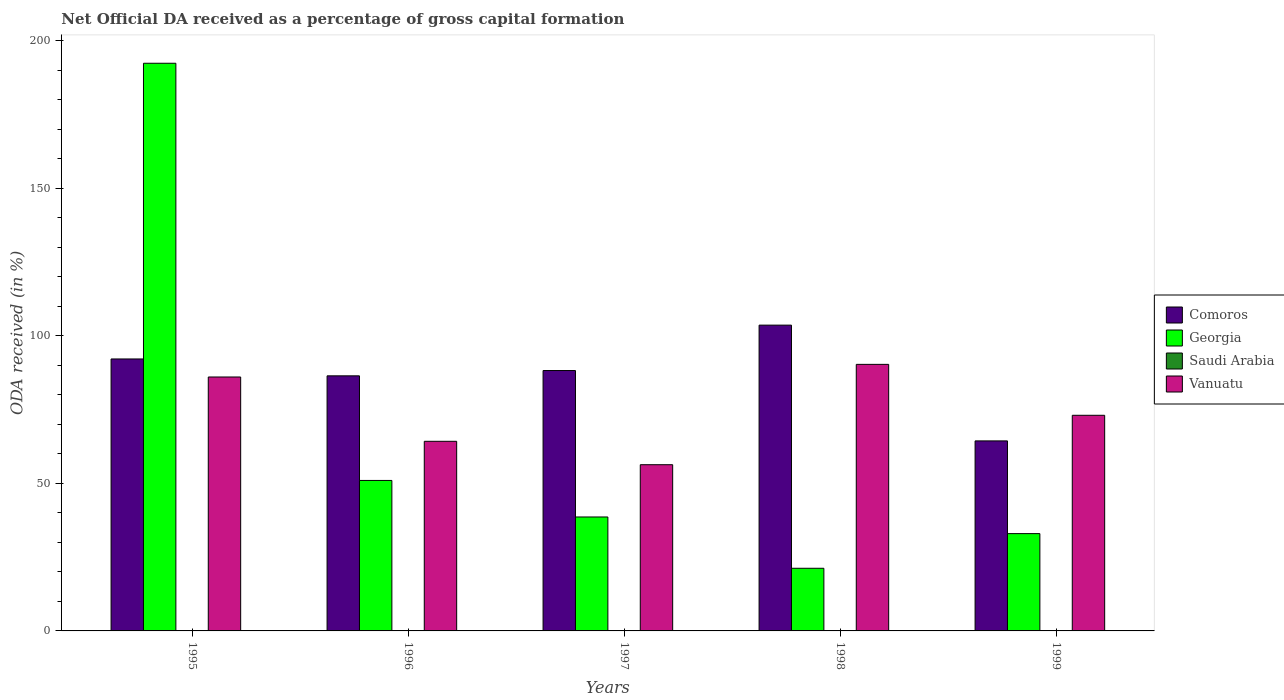How many groups of bars are there?
Keep it short and to the point. 5. Are the number of bars on each tick of the X-axis equal?
Offer a terse response. Yes. How many bars are there on the 2nd tick from the left?
Provide a short and direct response. 4. In how many cases, is the number of bars for a given year not equal to the number of legend labels?
Your answer should be very brief. 0. What is the net ODA received in Comoros in 1998?
Your answer should be very brief. 103.67. Across all years, what is the maximum net ODA received in Georgia?
Offer a very short reply. 192.44. Across all years, what is the minimum net ODA received in Comoros?
Make the answer very short. 64.42. In which year was the net ODA received in Saudi Arabia maximum?
Your answer should be compact. 1999. What is the total net ODA received in Saudi Arabia in the graph?
Ensure brevity in your answer.  0.23. What is the difference between the net ODA received in Saudi Arabia in 1998 and that in 1999?
Ensure brevity in your answer.  -0.01. What is the difference between the net ODA received in Georgia in 1996 and the net ODA received in Comoros in 1999?
Your answer should be very brief. -13.41. What is the average net ODA received in Saudi Arabia per year?
Make the answer very short. 0.05. In the year 1996, what is the difference between the net ODA received in Saudi Arabia and net ODA received in Comoros?
Give a very brief answer. -86.43. What is the ratio of the net ODA received in Vanuatu in 1998 to that in 1999?
Provide a short and direct response. 1.24. What is the difference between the highest and the second highest net ODA received in Saudi Arabia?
Provide a short and direct response. 0. What is the difference between the highest and the lowest net ODA received in Georgia?
Offer a terse response. 171.2. What does the 3rd bar from the left in 1996 represents?
Make the answer very short. Saudi Arabia. What does the 4th bar from the right in 1997 represents?
Your answer should be very brief. Comoros. How many bars are there?
Make the answer very short. 20. Are all the bars in the graph horizontal?
Provide a succinct answer. No. How many years are there in the graph?
Provide a succinct answer. 5. What is the difference between two consecutive major ticks on the Y-axis?
Ensure brevity in your answer.  50. Are the values on the major ticks of Y-axis written in scientific E-notation?
Your answer should be compact. No. Does the graph contain any zero values?
Offer a very short reply. No. Does the graph contain grids?
Give a very brief answer. No. How many legend labels are there?
Provide a short and direct response. 4. How are the legend labels stacked?
Offer a very short reply. Vertical. What is the title of the graph?
Keep it short and to the point. Net Official DA received as a percentage of gross capital formation. Does "Ghana" appear as one of the legend labels in the graph?
Your response must be concise. No. What is the label or title of the Y-axis?
Your answer should be very brief. ODA received (in %). What is the ODA received (in %) in Comoros in 1995?
Provide a succinct answer. 92.2. What is the ODA received (in %) of Georgia in 1995?
Your answer should be compact. 192.44. What is the ODA received (in %) of Saudi Arabia in 1995?
Your answer should be compact. 0.06. What is the ODA received (in %) in Vanuatu in 1995?
Your answer should be very brief. 86.09. What is the ODA received (in %) in Comoros in 1996?
Your response must be concise. 86.48. What is the ODA received (in %) in Georgia in 1996?
Keep it short and to the point. 51.01. What is the ODA received (in %) in Saudi Arabia in 1996?
Keep it short and to the point. 0.05. What is the ODA received (in %) of Vanuatu in 1996?
Give a very brief answer. 64.28. What is the ODA received (in %) of Comoros in 1997?
Your answer should be very brief. 88.27. What is the ODA received (in %) of Georgia in 1997?
Keep it short and to the point. 38.63. What is the ODA received (in %) of Saudi Arabia in 1997?
Provide a short and direct response. 0. What is the ODA received (in %) of Vanuatu in 1997?
Ensure brevity in your answer.  56.35. What is the ODA received (in %) in Comoros in 1998?
Keep it short and to the point. 103.67. What is the ODA received (in %) of Georgia in 1998?
Your answer should be very brief. 21.24. What is the ODA received (in %) of Saudi Arabia in 1998?
Keep it short and to the point. 0.05. What is the ODA received (in %) in Vanuatu in 1998?
Offer a terse response. 90.36. What is the ODA received (in %) in Comoros in 1999?
Provide a short and direct response. 64.42. What is the ODA received (in %) of Georgia in 1999?
Give a very brief answer. 32.99. What is the ODA received (in %) in Saudi Arabia in 1999?
Give a very brief answer. 0.07. What is the ODA received (in %) of Vanuatu in 1999?
Keep it short and to the point. 73.1. Across all years, what is the maximum ODA received (in %) in Comoros?
Provide a succinct answer. 103.67. Across all years, what is the maximum ODA received (in %) in Georgia?
Your answer should be very brief. 192.44. Across all years, what is the maximum ODA received (in %) of Saudi Arabia?
Your answer should be compact. 0.07. Across all years, what is the maximum ODA received (in %) of Vanuatu?
Your response must be concise. 90.36. Across all years, what is the minimum ODA received (in %) in Comoros?
Provide a short and direct response. 64.42. Across all years, what is the minimum ODA received (in %) of Georgia?
Provide a succinct answer. 21.24. Across all years, what is the minimum ODA received (in %) in Saudi Arabia?
Provide a succinct answer. 0. Across all years, what is the minimum ODA received (in %) in Vanuatu?
Offer a very short reply. 56.35. What is the total ODA received (in %) of Comoros in the graph?
Provide a succinct answer. 435.03. What is the total ODA received (in %) in Georgia in the graph?
Your answer should be compact. 336.31. What is the total ODA received (in %) in Saudi Arabia in the graph?
Offer a terse response. 0.23. What is the total ODA received (in %) of Vanuatu in the graph?
Your response must be concise. 370.18. What is the difference between the ODA received (in %) in Comoros in 1995 and that in 1996?
Your response must be concise. 5.72. What is the difference between the ODA received (in %) in Georgia in 1995 and that in 1996?
Offer a terse response. 141.43. What is the difference between the ODA received (in %) of Saudi Arabia in 1995 and that in 1996?
Your response must be concise. 0.01. What is the difference between the ODA received (in %) in Vanuatu in 1995 and that in 1996?
Ensure brevity in your answer.  21.81. What is the difference between the ODA received (in %) of Comoros in 1995 and that in 1997?
Offer a very short reply. 3.93. What is the difference between the ODA received (in %) in Georgia in 1995 and that in 1997?
Offer a terse response. 153.81. What is the difference between the ODA received (in %) in Saudi Arabia in 1995 and that in 1997?
Provide a succinct answer. 0.06. What is the difference between the ODA received (in %) of Vanuatu in 1995 and that in 1997?
Your answer should be compact. 29.74. What is the difference between the ODA received (in %) in Comoros in 1995 and that in 1998?
Ensure brevity in your answer.  -11.47. What is the difference between the ODA received (in %) of Georgia in 1995 and that in 1998?
Your response must be concise. 171.2. What is the difference between the ODA received (in %) of Saudi Arabia in 1995 and that in 1998?
Make the answer very short. 0.01. What is the difference between the ODA received (in %) of Vanuatu in 1995 and that in 1998?
Your answer should be compact. -4.28. What is the difference between the ODA received (in %) of Comoros in 1995 and that in 1999?
Your answer should be very brief. 27.78. What is the difference between the ODA received (in %) in Georgia in 1995 and that in 1999?
Offer a terse response. 159.45. What is the difference between the ODA received (in %) in Saudi Arabia in 1995 and that in 1999?
Provide a succinct answer. -0. What is the difference between the ODA received (in %) of Vanuatu in 1995 and that in 1999?
Your response must be concise. 12.98. What is the difference between the ODA received (in %) in Comoros in 1996 and that in 1997?
Make the answer very short. -1.79. What is the difference between the ODA received (in %) in Georgia in 1996 and that in 1997?
Your answer should be compact. 12.38. What is the difference between the ODA received (in %) of Saudi Arabia in 1996 and that in 1997?
Provide a short and direct response. 0.04. What is the difference between the ODA received (in %) in Vanuatu in 1996 and that in 1997?
Keep it short and to the point. 7.93. What is the difference between the ODA received (in %) of Comoros in 1996 and that in 1998?
Offer a terse response. -17.19. What is the difference between the ODA received (in %) in Georgia in 1996 and that in 1998?
Your response must be concise. 29.77. What is the difference between the ODA received (in %) of Saudi Arabia in 1996 and that in 1998?
Provide a short and direct response. -0. What is the difference between the ODA received (in %) in Vanuatu in 1996 and that in 1998?
Your response must be concise. -26.08. What is the difference between the ODA received (in %) of Comoros in 1996 and that in 1999?
Give a very brief answer. 22.06. What is the difference between the ODA received (in %) in Georgia in 1996 and that in 1999?
Your answer should be compact. 18.02. What is the difference between the ODA received (in %) in Saudi Arabia in 1996 and that in 1999?
Provide a succinct answer. -0.02. What is the difference between the ODA received (in %) in Vanuatu in 1996 and that in 1999?
Ensure brevity in your answer.  -8.82. What is the difference between the ODA received (in %) of Comoros in 1997 and that in 1998?
Offer a very short reply. -15.4. What is the difference between the ODA received (in %) in Georgia in 1997 and that in 1998?
Offer a terse response. 17.39. What is the difference between the ODA received (in %) in Saudi Arabia in 1997 and that in 1998?
Your answer should be very brief. -0.05. What is the difference between the ODA received (in %) of Vanuatu in 1997 and that in 1998?
Your response must be concise. -34.02. What is the difference between the ODA received (in %) in Comoros in 1997 and that in 1999?
Offer a very short reply. 23.85. What is the difference between the ODA received (in %) of Georgia in 1997 and that in 1999?
Your response must be concise. 5.64. What is the difference between the ODA received (in %) of Saudi Arabia in 1997 and that in 1999?
Keep it short and to the point. -0.06. What is the difference between the ODA received (in %) in Vanuatu in 1997 and that in 1999?
Ensure brevity in your answer.  -16.76. What is the difference between the ODA received (in %) of Comoros in 1998 and that in 1999?
Your answer should be compact. 39.25. What is the difference between the ODA received (in %) in Georgia in 1998 and that in 1999?
Keep it short and to the point. -11.75. What is the difference between the ODA received (in %) in Saudi Arabia in 1998 and that in 1999?
Your response must be concise. -0.01. What is the difference between the ODA received (in %) of Vanuatu in 1998 and that in 1999?
Your answer should be compact. 17.26. What is the difference between the ODA received (in %) in Comoros in 1995 and the ODA received (in %) in Georgia in 1996?
Offer a very short reply. 41.19. What is the difference between the ODA received (in %) in Comoros in 1995 and the ODA received (in %) in Saudi Arabia in 1996?
Give a very brief answer. 92.15. What is the difference between the ODA received (in %) of Comoros in 1995 and the ODA received (in %) of Vanuatu in 1996?
Provide a succinct answer. 27.92. What is the difference between the ODA received (in %) of Georgia in 1995 and the ODA received (in %) of Saudi Arabia in 1996?
Your answer should be very brief. 192.39. What is the difference between the ODA received (in %) in Georgia in 1995 and the ODA received (in %) in Vanuatu in 1996?
Give a very brief answer. 128.16. What is the difference between the ODA received (in %) of Saudi Arabia in 1995 and the ODA received (in %) of Vanuatu in 1996?
Offer a terse response. -64.22. What is the difference between the ODA received (in %) in Comoros in 1995 and the ODA received (in %) in Georgia in 1997?
Offer a terse response. 53.57. What is the difference between the ODA received (in %) of Comoros in 1995 and the ODA received (in %) of Saudi Arabia in 1997?
Make the answer very short. 92.19. What is the difference between the ODA received (in %) of Comoros in 1995 and the ODA received (in %) of Vanuatu in 1997?
Ensure brevity in your answer.  35.85. What is the difference between the ODA received (in %) in Georgia in 1995 and the ODA received (in %) in Saudi Arabia in 1997?
Ensure brevity in your answer.  192.44. What is the difference between the ODA received (in %) in Georgia in 1995 and the ODA received (in %) in Vanuatu in 1997?
Your answer should be very brief. 136.09. What is the difference between the ODA received (in %) of Saudi Arabia in 1995 and the ODA received (in %) of Vanuatu in 1997?
Make the answer very short. -56.29. What is the difference between the ODA received (in %) in Comoros in 1995 and the ODA received (in %) in Georgia in 1998?
Your answer should be very brief. 70.96. What is the difference between the ODA received (in %) of Comoros in 1995 and the ODA received (in %) of Saudi Arabia in 1998?
Your answer should be very brief. 92.15. What is the difference between the ODA received (in %) of Comoros in 1995 and the ODA received (in %) of Vanuatu in 1998?
Keep it short and to the point. 1.84. What is the difference between the ODA received (in %) in Georgia in 1995 and the ODA received (in %) in Saudi Arabia in 1998?
Keep it short and to the point. 192.39. What is the difference between the ODA received (in %) of Georgia in 1995 and the ODA received (in %) of Vanuatu in 1998?
Provide a succinct answer. 102.08. What is the difference between the ODA received (in %) in Saudi Arabia in 1995 and the ODA received (in %) in Vanuatu in 1998?
Your answer should be compact. -90.3. What is the difference between the ODA received (in %) in Comoros in 1995 and the ODA received (in %) in Georgia in 1999?
Your response must be concise. 59.21. What is the difference between the ODA received (in %) of Comoros in 1995 and the ODA received (in %) of Saudi Arabia in 1999?
Keep it short and to the point. 92.13. What is the difference between the ODA received (in %) of Comoros in 1995 and the ODA received (in %) of Vanuatu in 1999?
Your answer should be compact. 19.1. What is the difference between the ODA received (in %) in Georgia in 1995 and the ODA received (in %) in Saudi Arabia in 1999?
Your answer should be compact. 192.38. What is the difference between the ODA received (in %) in Georgia in 1995 and the ODA received (in %) in Vanuatu in 1999?
Your response must be concise. 119.34. What is the difference between the ODA received (in %) of Saudi Arabia in 1995 and the ODA received (in %) of Vanuatu in 1999?
Make the answer very short. -73.04. What is the difference between the ODA received (in %) in Comoros in 1996 and the ODA received (in %) in Georgia in 1997?
Your answer should be compact. 47.85. What is the difference between the ODA received (in %) of Comoros in 1996 and the ODA received (in %) of Saudi Arabia in 1997?
Provide a succinct answer. 86.47. What is the difference between the ODA received (in %) in Comoros in 1996 and the ODA received (in %) in Vanuatu in 1997?
Provide a short and direct response. 30.13. What is the difference between the ODA received (in %) in Georgia in 1996 and the ODA received (in %) in Saudi Arabia in 1997?
Make the answer very short. 51.01. What is the difference between the ODA received (in %) of Georgia in 1996 and the ODA received (in %) of Vanuatu in 1997?
Give a very brief answer. -5.34. What is the difference between the ODA received (in %) of Saudi Arabia in 1996 and the ODA received (in %) of Vanuatu in 1997?
Provide a short and direct response. -56.3. What is the difference between the ODA received (in %) in Comoros in 1996 and the ODA received (in %) in Georgia in 1998?
Your answer should be compact. 65.24. What is the difference between the ODA received (in %) in Comoros in 1996 and the ODA received (in %) in Saudi Arabia in 1998?
Your answer should be very brief. 86.43. What is the difference between the ODA received (in %) of Comoros in 1996 and the ODA received (in %) of Vanuatu in 1998?
Ensure brevity in your answer.  -3.89. What is the difference between the ODA received (in %) of Georgia in 1996 and the ODA received (in %) of Saudi Arabia in 1998?
Your answer should be very brief. 50.96. What is the difference between the ODA received (in %) of Georgia in 1996 and the ODA received (in %) of Vanuatu in 1998?
Provide a succinct answer. -39.35. What is the difference between the ODA received (in %) of Saudi Arabia in 1996 and the ODA received (in %) of Vanuatu in 1998?
Provide a short and direct response. -90.31. What is the difference between the ODA received (in %) in Comoros in 1996 and the ODA received (in %) in Georgia in 1999?
Give a very brief answer. 53.49. What is the difference between the ODA received (in %) in Comoros in 1996 and the ODA received (in %) in Saudi Arabia in 1999?
Your answer should be compact. 86.41. What is the difference between the ODA received (in %) of Comoros in 1996 and the ODA received (in %) of Vanuatu in 1999?
Keep it short and to the point. 13.37. What is the difference between the ODA received (in %) in Georgia in 1996 and the ODA received (in %) in Saudi Arabia in 1999?
Your answer should be compact. 50.95. What is the difference between the ODA received (in %) of Georgia in 1996 and the ODA received (in %) of Vanuatu in 1999?
Ensure brevity in your answer.  -22.09. What is the difference between the ODA received (in %) of Saudi Arabia in 1996 and the ODA received (in %) of Vanuatu in 1999?
Make the answer very short. -73.05. What is the difference between the ODA received (in %) in Comoros in 1997 and the ODA received (in %) in Georgia in 1998?
Provide a succinct answer. 67.03. What is the difference between the ODA received (in %) of Comoros in 1997 and the ODA received (in %) of Saudi Arabia in 1998?
Offer a very short reply. 88.22. What is the difference between the ODA received (in %) of Comoros in 1997 and the ODA received (in %) of Vanuatu in 1998?
Provide a succinct answer. -2.09. What is the difference between the ODA received (in %) in Georgia in 1997 and the ODA received (in %) in Saudi Arabia in 1998?
Your answer should be very brief. 38.58. What is the difference between the ODA received (in %) in Georgia in 1997 and the ODA received (in %) in Vanuatu in 1998?
Offer a terse response. -51.74. What is the difference between the ODA received (in %) in Saudi Arabia in 1997 and the ODA received (in %) in Vanuatu in 1998?
Provide a short and direct response. -90.36. What is the difference between the ODA received (in %) in Comoros in 1997 and the ODA received (in %) in Georgia in 1999?
Provide a succinct answer. 55.28. What is the difference between the ODA received (in %) of Comoros in 1997 and the ODA received (in %) of Saudi Arabia in 1999?
Offer a terse response. 88.2. What is the difference between the ODA received (in %) of Comoros in 1997 and the ODA received (in %) of Vanuatu in 1999?
Make the answer very short. 15.17. What is the difference between the ODA received (in %) of Georgia in 1997 and the ODA received (in %) of Saudi Arabia in 1999?
Ensure brevity in your answer.  38.56. What is the difference between the ODA received (in %) of Georgia in 1997 and the ODA received (in %) of Vanuatu in 1999?
Offer a terse response. -34.48. What is the difference between the ODA received (in %) in Saudi Arabia in 1997 and the ODA received (in %) in Vanuatu in 1999?
Offer a very short reply. -73.1. What is the difference between the ODA received (in %) of Comoros in 1998 and the ODA received (in %) of Georgia in 1999?
Provide a short and direct response. 70.68. What is the difference between the ODA received (in %) of Comoros in 1998 and the ODA received (in %) of Saudi Arabia in 1999?
Offer a very short reply. 103.6. What is the difference between the ODA received (in %) in Comoros in 1998 and the ODA received (in %) in Vanuatu in 1999?
Offer a very short reply. 30.56. What is the difference between the ODA received (in %) in Georgia in 1998 and the ODA received (in %) in Saudi Arabia in 1999?
Your answer should be very brief. 21.17. What is the difference between the ODA received (in %) of Georgia in 1998 and the ODA received (in %) of Vanuatu in 1999?
Offer a very short reply. -51.86. What is the difference between the ODA received (in %) in Saudi Arabia in 1998 and the ODA received (in %) in Vanuatu in 1999?
Your response must be concise. -73.05. What is the average ODA received (in %) in Comoros per year?
Your response must be concise. 87.01. What is the average ODA received (in %) of Georgia per year?
Your response must be concise. 67.26. What is the average ODA received (in %) of Saudi Arabia per year?
Your answer should be compact. 0.05. What is the average ODA received (in %) of Vanuatu per year?
Provide a short and direct response. 74.04. In the year 1995, what is the difference between the ODA received (in %) in Comoros and ODA received (in %) in Georgia?
Ensure brevity in your answer.  -100.24. In the year 1995, what is the difference between the ODA received (in %) in Comoros and ODA received (in %) in Saudi Arabia?
Ensure brevity in your answer.  92.14. In the year 1995, what is the difference between the ODA received (in %) in Comoros and ODA received (in %) in Vanuatu?
Provide a short and direct response. 6.11. In the year 1995, what is the difference between the ODA received (in %) in Georgia and ODA received (in %) in Saudi Arabia?
Keep it short and to the point. 192.38. In the year 1995, what is the difference between the ODA received (in %) in Georgia and ODA received (in %) in Vanuatu?
Offer a very short reply. 106.36. In the year 1995, what is the difference between the ODA received (in %) of Saudi Arabia and ODA received (in %) of Vanuatu?
Offer a very short reply. -86.03. In the year 1996, what is the difference between the ODA received (in %) in Comoros and ODA received (in %) in Georgia?
Offer a very short reply. 35.47. In the year 1996, what is the difference between the ODA received (in %) of Comoros and ODA received (in %) of Saudi Arabia?
Provide a succinct answer. 86.43. In the year 1996, what is the difference between the ODA received (in %) of Comoros and ODA received (in %) of Vanuatu?
Your response must be concise. 22.2. In the year 1996, what is the difference between the ODA received (in %) in Georgia and ODA received (in %) in Saudi Arabia?
Your answer should be compact. 50.96. In the year 1996, what is the difference between the ODA received (in %) of Georgia and ODA received (in %) of Vanuatu?
Provide a short and direct response. -13.27. In the year 1996, what is the difference between the ODA received (in %) in Saudi Arabia and ODA received (in %) in Vanuatu?
Your response must be concise. -64.23. In the year 1997, what is the difference between the ODA received (in %) in Comoros and ODA received (in %) in Georgia?
Keep it short and to the point. 49.64. In the year 1997, what is the difference between the ODA received (in %) in Comoros and ODA received (in %) in Saudi Arabia?
Your answer should be compact. 88.26. In the year 1997, what is the difference between the ODA received (in %) of Comoros and ODA received (in %) of Vanuatu?
Provide a succinct answer. 31.92. In the year 1997, what is the difference between the ODA received (in %) of Georgia and ODA received (in %) of Saudi Arabia?
Your response must be concise. 38.62. In the year 1997, what is the difference between the ODA received (in %) in Georgia and ODA received (in %) in Vanuatu?
Provide a succinct answer. -17.72. In the year 1997, what is the difference between the ODA received (in %) of Saudi Arabia and ODA received (in %) of Vanuatu?
Your response must be concise. -56.34. In the year 1998, what is the difference between the ODA received (in %) of Comoros and ODA received (in %) of Georgia?
Give a very brief answer. 82.43. In the year 1998, what is the difference between the ODA received (in %) of Comoros and ODA received (in %) of Saudi Arabia?
Ensure brevity in your answer.  103.61. In the year 1998, what is the difference between the ODA received (in %) in Comoros and ODA received (in %) in Vanuatu?
Your response must be concise. 13.3. In the year 1998, what is the difference between the ODA received (in %) in Georgia and ODA received (in %) in Saudi Arabia?
Offer a very short reply. 21.19. In the year 1998, what is the difference between the ODA received (in %) of Georgia and ODA received (in %) of Vanuatu?
Give a very brief answer. -69.12. In the year 1998, what is the difference between the ODA received (in %) in Saudi Arabia and ODA received (in %) in Vanuatu?
Provide a short and direct response. -90.31. In the year 1999, what is the difference between the ODA received (in %) in Comoros and ODA received (in %) in Georgia?
Offer a terse response. 31.43. In the year 1999, what is the difference between the ODA received (in %) of Comoros and ODA received (in %) of Saudi Arabia?
Provide a short and direct response. 64.35. In the year 1999, what is the difference between the ODA received (in %) of Comoros and ODA received (in %) of Vanuatu?
Your answer should be compact. -8.68. In the year 1999, what is the difference between the ODA received (in %) of Georgia and ODA received (in %) of Saudi Arabia?
Your response must be concise. 32.92. In the year 1999, what is the difference between the ODA received (in %) of Georgia and ODA received (in %) of Vanuatu?
Your answer should be compact. -40.12. In the year 1999, what is the difference between the ODA received (in %) in Saudi Arabia and ODA received (in %) in Vanuatu?
Your response must be concise. -73.04. What is the ratio of the ODA received (in %) in Comoros in 1995 to that in 1996?
Give a very brief answer. 1.07. What is the ratio of the ODA received (in %) of Georgia in 1995 to that in 1996?
Give a very brief answer. 3.77. What is the ratio of the ODA received (in %) in Saudi Arabia in 1995 to that in 1996?
Offer a very short reply. 1.22. What is the ratio of the ODA received (in %) of Vanuatu in 1995 to that in 1996?
Your response must be concise. 1.34. What is the ratio of the ODA received (in %) in Comoros in 1995 to that in 1997?
Make the answer very short. 1.04. What is the ratio of the ODA received (in %) of Georgia in 1995 to that in 1997?
Provide a succinct answer. 4.98. What is the ratio of the ODA received (in %) in Saudi Arabia in 1995 to that in 1997?
Offer a terse response. 13.19. What is the ratio of the ODA received (in %) in Vanuatu in 1995 to that in 1997?
Give a very brief answer. 1.53. What is the ratio of the ODA received (in %) in Comoros in 1995 to that in 1998?
Provide a succinct answer. 0.89. What is the ratio of the ODA received (in %) of Georgia in 1995 to that in 1998?
Your response must be concise. 9.06. What is the ratio of the ODA received (in %) of Saudi Arabia in 1995 to that in 1998?
Offer a very short reply. 1.19. What is the ratio of the ODA received (in %) in Vanuatu in 1995 to that in 1998?
Give a very brief answer. 0.95. What is the ratio of the ODA received (in %) of Comoros in 1995 to that in 1999?
Your answer should be compact. 1.43. What is the ratio of the ODA received (in %) of Georgia in 1995 to that in 1999?
Your response must be concise. 5.83. What is the ratio of the ODA received (in %) of Saudi Arabia in 1995 to that in 1999?
Offer a very short reply. 0.93. What is the ratio of the ODA received (in %) of Vanuatu in 1995 to that in 1999?
Your answer should be very brief. 1.18. What is the ratio of the ODA received (in %) of Comoros in 1996 to that in 1997?
Offer a terse response. 0.98. What is the ratio of the ODA received (in %) in Georgia in 1996 to that in 1997?
Keep it short and to the point. 1.32. What is the ratio of the ODA received (in %) in Saudi Arabia in 1996 to that in 1997?
Give a very brief answer. 10.79. What is the ratio of the ODA received (in %) of Vanuatu in 1996 to that in 1997?
Give a very brief answer. 1.14. What is the ratio of the ODA received (in %) in Comoros in 1996 to that in 1998?
Ensure brevity in your answer.  0.83. What is the ratio of the ODA received (in %) of Georgia in 1996 to that in 1998?
Ensure brevity in your answer.  2.4. What is the ratio of the ODA received (in %) in Saudi Arabia in 1996 to that in 1998?
Provide a short and direct response. 0.97. What is the ratio of the ODA received (in %) of Vanuatu in 1996 to that in 1998?
Provide a succinct answer. 0.71. What is the ratio of the ODA received (in %) in Comoros in 1996 to that in 1999?
Provide a short and direct response. 1.34. What is the ratio of the ODA received (in %) in Georgia in 1996 to that in 1999?
Give a very brief answer. 1.55. What is the ratio of the ODA received (in %) of Saudi Arabia in 1996 to that in 1999?
Your response must be concise. 0.76. What is the ratio of the ODA received (in %) in Vanuatu in 1996 to that in 1999?
Offer a terse response. 0.88. What is the ratio of the ODA received (in %) of Comoros in 1997 to that in 1998?
Make the answer very short. 0.85. What is the ratio of the ODA received (in %) of Georgia in 1997 to that in 1998?
Give a very brief answer. 1.82. What is the ratio of the ODA received (in %) in Saudi Arabia in 1997 to that in 1998?
Provide a succinct answer. 0.09. What is the ratio of the ODA received (in %) of Vanuatu in 1997 to that in 1998?
Your response must be concise. 0.62. What is the ratio of the ODA received (in %) of Comoros in 1997 to that in 1999?
Ensure brevity in your answer.  1.37. What is the ratio of the ODA received (in %) of Georgia in 1997 to that in 1999?
Make the answer very short. 1.17. What is the ratio of the ODA received (in %) of Saudi Arabia in 1997 to that in 1999?
Offer a very short reply. 0.07. What is the ratio of the ODA received (in %) in Vanuatu in 1997 to that in 1999?
Keep it short and to the point. 0.77. What is the ratio of the ODA received (in %) of Comoros in 1998 to that in 1999?
Offer a terse response. 1.61. What is the ratio of the ODA received (in %) in Georgia in 1998 to that in 1999?
Provide a short and direct response. 0.64. What is the ratio of the ODA received (in %) of Saudi Arabia in 1998 to that in 1999?
Provide a short and direct response. 0.78. What is the ratio of the ODA received (in %) of Vanuatu in 1998 to that in 1999?
Provide a short and direct response. 1.24. What is the difference between the highest and the second highest ODA received (in %) in Comoros?
Ensure brevity in your answer.  11.47. What is the difference between the highest and the second highest ODA received (in %) in Georgia?
Provide a short and direct response. 141.43. What is the difference between the highest and the second highest ODA received (in %) in Saudi Arabia?
Make the answer very short. 0. What is the difference between the highest and the second highest ODA received (in %) in Vanuatu?
Provide a succinct answer. 4.28. What is the difference between the highest and the lowest ODA received (in %) in Comoros?
Your response must be concise. 39.25. What is the difference between the highest and the lowest ODA received (in %) in Georgia?
Provide a short and direct response. 171.2. What is the difference between the highest and the lowest ODA received (in %) in Saudi Arabia?
Give a very brief answer. 0.06. What is the difference between the highest and the lowest ODA received (in %) in Vanuatu?
Offer a terse response. 34.02. 